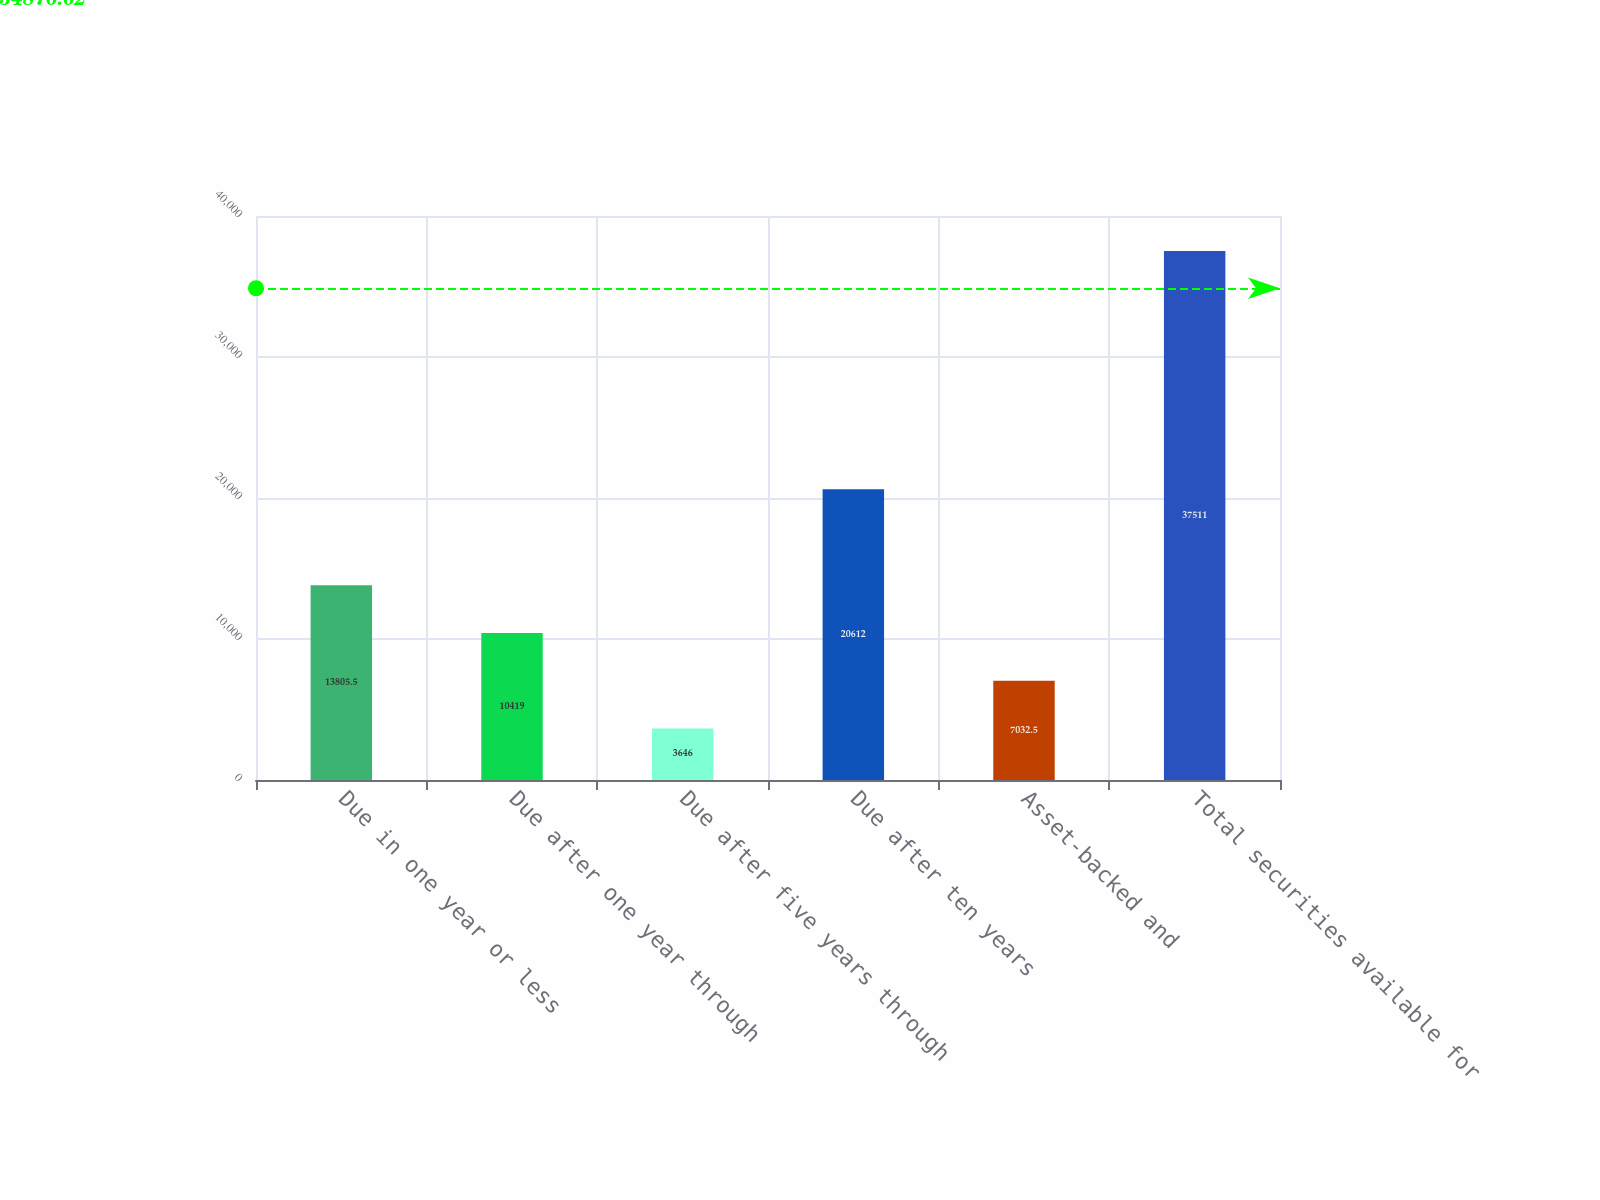Convert chart to OTSL. <chart><loc_0><loc_0><loc_500><loc_500><bar_chart><fcel>Due in one year or less<fcel>Due after one year through<fcel>Due after five years through<fcel>Due after ten years<fcel>Asset-backed and<fcel>Total securities available for<nl><fcel>13805.5<fcel>10419<fcel>3646<fcel>20612<fcel>7032.5<fcel>37511<nl></chart> 